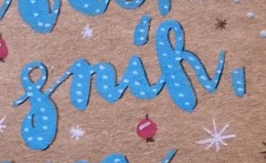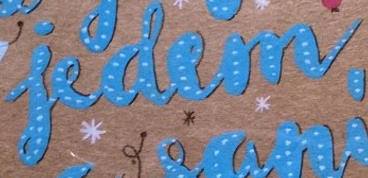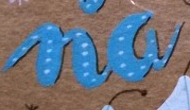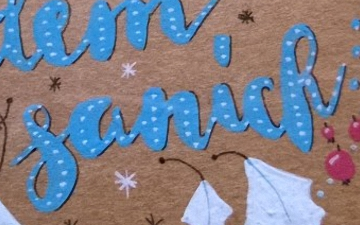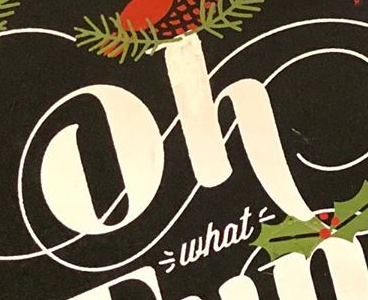What text appears in these images from left to right, separated by a semicolon? snik,; iedem; na; sanick; oh 